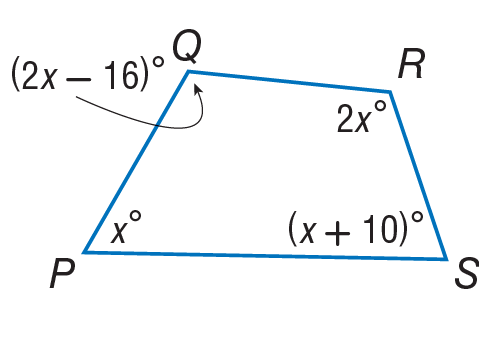Answer the mathemtical geometry problem and directly provide the correct option letter.
Question: Find the measure of \angle R.
Choices: A: 5 B: 40 C: 78 D: 122 D 